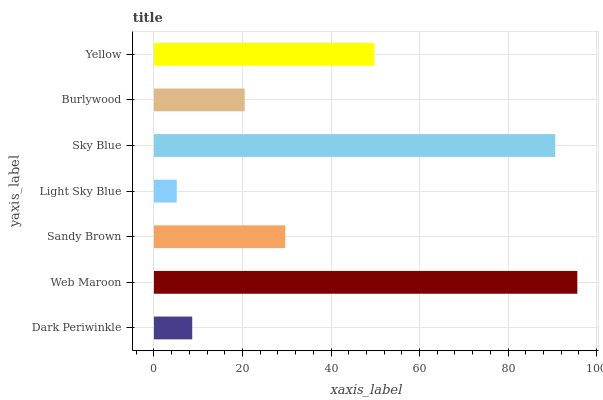Is Light Sky Blue the minimum?
Answer yes or no. Yes. Is Web Maroon the maximum?
Answer yes or no. Yes. Is Sandy Brown the minimum?
Answer yes or no. No. Is Sandy Brown the maximum?
Answer yes or no. No. Is Web Maroon greater than Sandy Brown?
Answer yes or no. Yes. Is Sandy Brown less than Web Maroon?
Answer yes or no. Yes. Is Sandy Brown greater than Web Maroon?
Answer yes or no. No. Is Web Maroon less than Sandy Brown?
Answer yes or no. No. Is Sandy Brown the high median?
Answer yes or no. Yes. Is Sandy Brown the low median?
Answer yes or no. Yes. Is Web Maroon the high median?
Answer yes or no. No. Is Dark Periwinkle the low median?
Answer yes or no. No. 